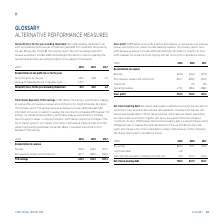According to Torm's financial document, How is net interest-bearing debt defined? Based on the financial document, the answer is borrowings (current and noncurrent) less loans receivables and cash and cash equivalents, including restricted cash. Also, What does TORM believe net interest-bearing debt to be? a relevant measure which Management uses to measure the overall development of the use of financing, other than equity. The document states: ", TORM believes that net interest-bearing debt is a relevant measure which Management uses to measure the overall development of the use of financing,..." Also, What are the components used to calculate net interest-bearing debt in the table? The document contains multiple relevant values: Borrowings, Loans receivables, Cash and cash equivalents, including restricted cash. From the document: "Cash and cash equivalents, including restricted cash -72.5 -127.4 -134.2 Loans receivables -4.6 - - Borrowings 863.4 754.7 753.9..." Additionally, In which year was the amount of Borrowings the lowest? According to the financial document, 2017. The relevant text states: "USDm 2019 2018 2017..." Also, can you calculate: What was the change in Net interest-bearing debt in 2019 from 2018? Based on the calculation: 786.3-627.3, the result is 159 (in millions). This is based on the information: "Net interest-bearing debt 786.3 627.3 619.7 Net interest-bearing debt 786.3 627.3 619.7..." The key data points involved are: 627.3, 786.3. Also, can you calculate: What was the percentage change in Net interest-bearing debt in 2019 from 2018? To answer this question, I need to perform calculations using the financial data. The calculation is: (786.3-627.3)/627.3, which equals 25.35 (percentage). This is based on the information: "Net interest-bearing debt 786.3 627.3 619.7 Net interest-bearing debt 786.3 627.3 619.7..." The key data points involved are: 627.3, 786.3. 